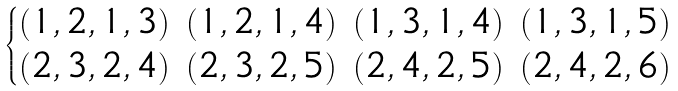Convert formula to latex. <formula><loc_0><loc_0><loc_500><loc_500>\begin{cases} \begin{matrix} ( 1 , 2 , 1 , 3 ) & ( 1 , 2 , 1 , 4 ) & ( 1 , 3 , 1 , 4 ) & ( 1 , 3 , 1 , 5 ) \\ ( 2 , 3 , 2 , 4 ) & ( 2 , 3 , 2 , 5 ) & ( 2 , 4 , 2 , 5 ) & ( 2 , 4 , 2 , 6 ) \end{matrix} \end{cases}</formula> 